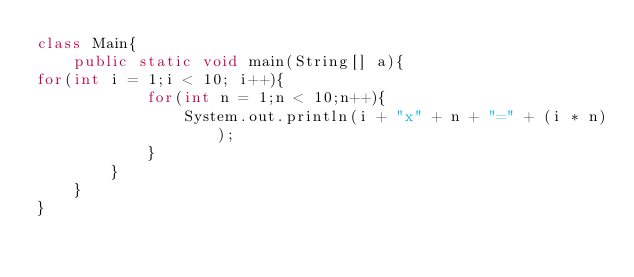Convert code to text. <code><loc_0><loc_0><loc_500><loc_500><_Java_>class Main{
    public static void main(String[] a){
for(int i = 1;i < 10; i++){
            for(int n = 1;n < 10;n++){
                System.out.println(i + "x" + n + "=" + (i * n));
            }
        }
    }
}</code> 